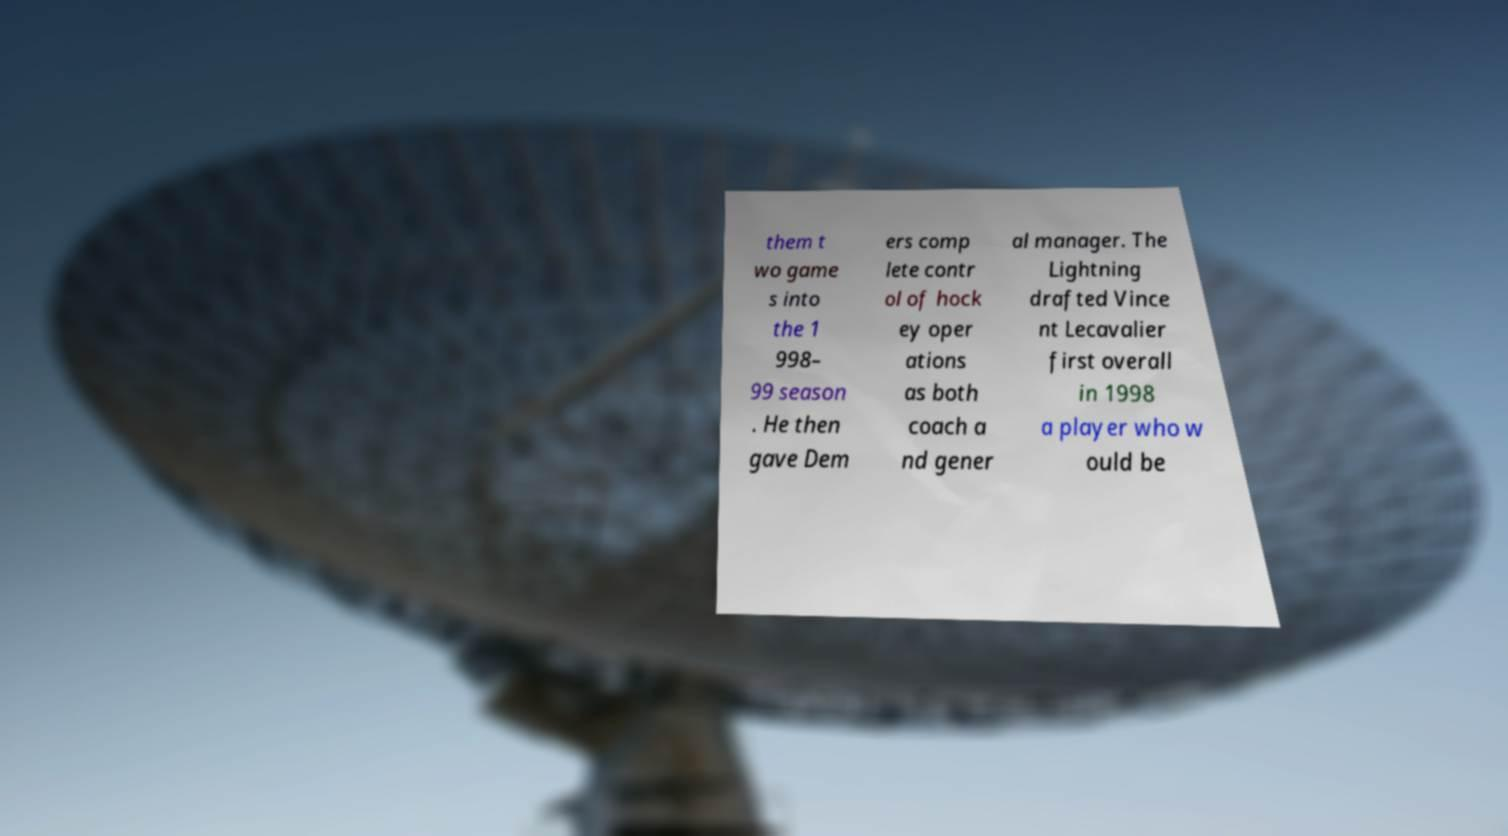Can you read and provide the text displayed in the image?This photo seems to have some interesting text. Can you extract and type it out for me? them t wo game s into the 1 998– 99 season . He then gave Dem ers comp lete contr ol of hock ey oper ations as both coach a nd gener al manager. The Lightning drafted Vince nt Lecavalier first overall in 1998 a player who w ould be 